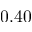<formula> <loc_0><loc_0><loc_500><loc_500>0 . 4 0</formula> 